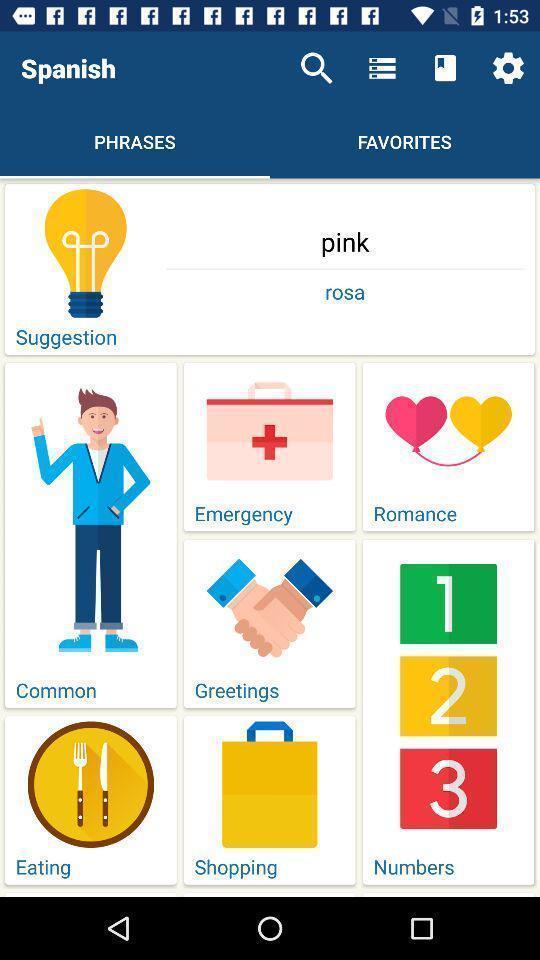Explain the elements present in this screenshot. Screen displaying multiple topics in a language learning application. 